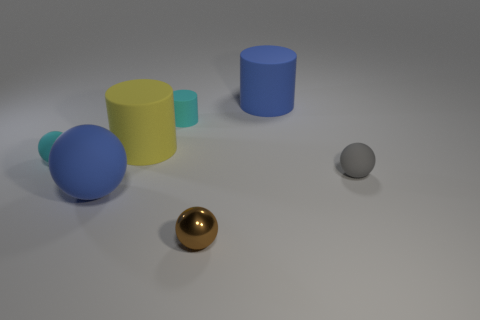How many large matte cylinders are both in front of the blue cylinder and right of the small metal object?
Ensure brevity in your answer.  0. What material is the cyan cylinder?
Provide a short and direct response. Rubber. Is there a large purple shiny object?
Your answer should be compact. No. What color is the small ball that is on the right side of the tiny brown sphere?
Keep it short and to the point. Gray. What number of rubber objects are right of the big blue rubber object to the left of the big matte cylinder that is in front of the cyan rubber cylinder?
Your answer should be compact. 4. What is the material of the thing that is behind the cyan rubber sphere and in front of the tiny matte cylinder?
Provide a succinct answer. Rubber. Does the gray sphere have the same material as the tiny cyan thing behind the large yellow matte thing?
Ensure brevity in your answer.  Yes. Are there more cyan cylinders left of the small brown shiny object than small cyan objects that are behind the cyan cylinder?
Your response must be concise. Yes. The large yellow object is what shape?
Offer a very short reply. Cylinder. Is the big blue thing that is on the left side of the cyan rubber cylinder made of the same material as the blue thing on the right side of the tiny cyan cylinder?
Offer a very short reply. Yes. 